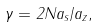<formula> <loc_0><loc_0><loc_500><loc_500>\gamma = 2 N a _ { s } / a _ { z } ,</formula> 